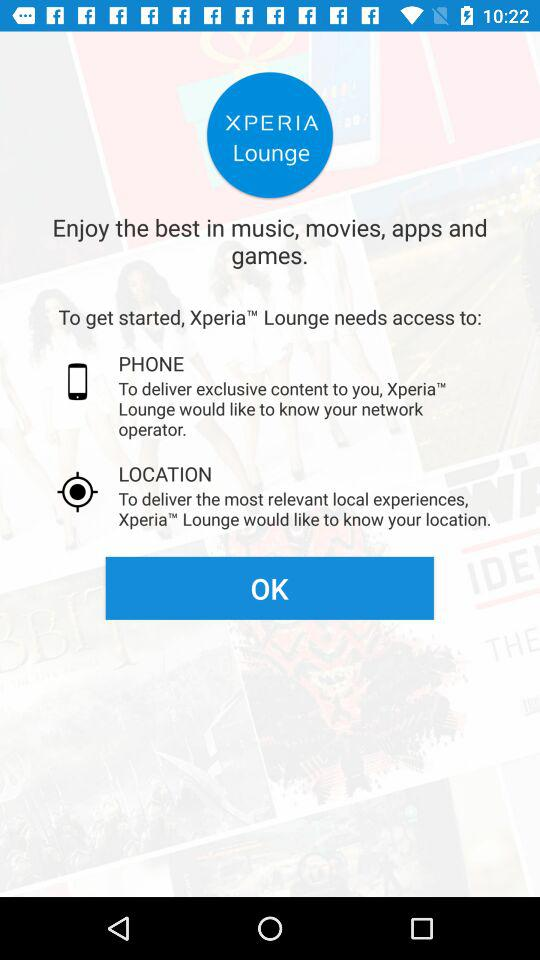How many data points does XperiaTM Lounge need to know to get started?
Answer the question using a single word or phrase. 2 